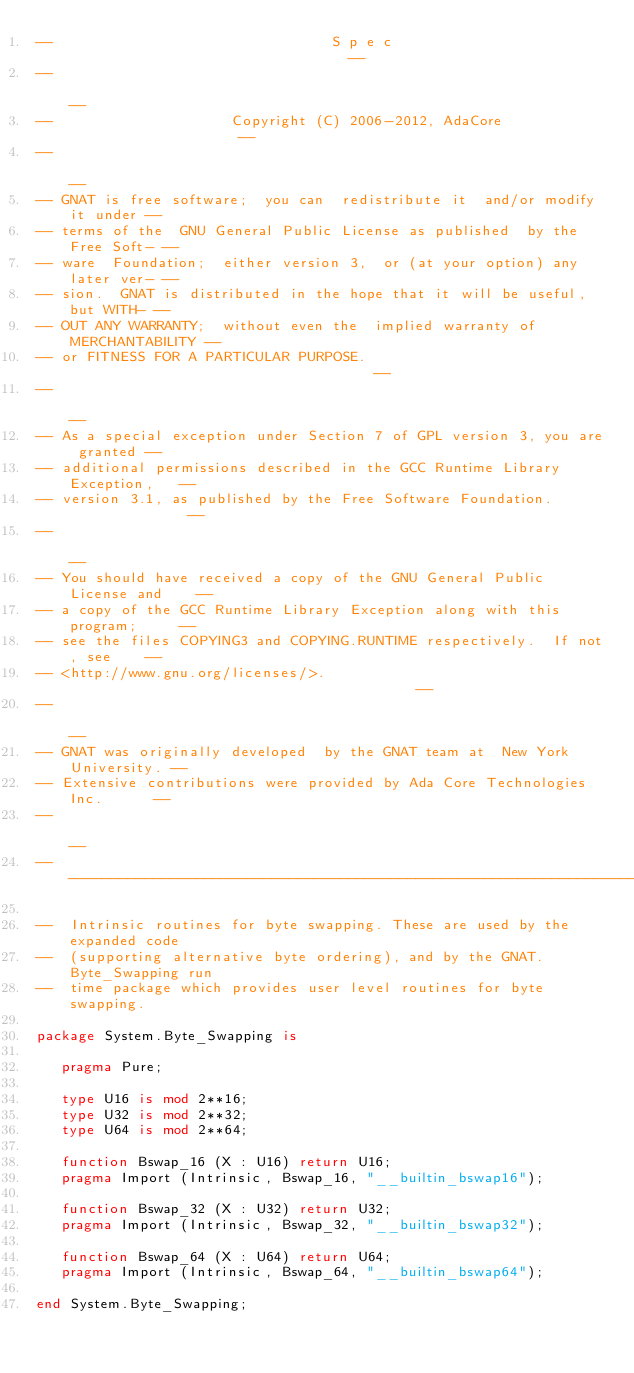Convert code to text. <code><loc_0><loc_0><loc_500><loc_500><_Ada_>--                                 S p e c                                  --
--                                                                          --
--                     Copyright (C) 2006-2012, AdaCore                     --
--                                                                          --
-- GNAT is free software;  you can  redistribute it  and/or modify it under --
-- terms of the  GNU General Public License as published  by the Free Soft- --
-- ware  Foundation;  either version 3,  or (at your option) any later ver- --
-- sion.  GNAT is distributed in the hope that it will be useful, but WITH- --
-- OUT ANY WARRANTY;  without even the  implied warranty of MERCHANTABILITY --
-- or FITNESS FOR A PARTICULAR PURPOSE.                                     --
--                                                                          --
-- As a special exception under Section 7 of GPL version 3, you are granted --
-- additional permissions described in the GCC Runtime Library Exception,   --
-- version 3.1, as published by the Free Software Foundation.               --
--                                                                          --
-- You should have received a copy of the GNU General Public License and    --
-- a copy of the GCC Runtime Library Exception along with this program;     --
-- see the files COPYING3 and COPYING.RUNTIME respectively.  If not, see    --
-- <http://www.gnu.org/licenses/>.                                          --
--                                                                          --
-- GNAT was originally developed  by the GNAT team at  New York University. --
-- Extensive contributions were provided by Ada Core Technologies Inc.      --
--                                                                          --
------------------------------------------------------------------------------

--  Intrinsic routines for byte swapping. These are used by the expanded code
--  (supporting alternative byte ordering), and by the GNAT.Byte_Swapping run
--  time package which provides user level routines for byte swapping.

package System.Byte_Swapping is

   pragma Pure;

   type U16 is mod 2**16;
   type U32 is mod 2**32;
   type U64 is mod 2**64;

   function Bswap_16 (X : U16) return U16;
   pragma Import (Intrinsic, Bswap_16, "__builtin_bswap16");

   function Bswap_32 (X : U32) return U32;
   pragma Import (Intrinsic, Bswap_32, "__builtin_bswap32");

   function Bswap_64 (X : U64) return U64;
   pragma Import (Intrinsic, Bswap_64, "__builtin_bswap64");

end System.Byte_Swapping;
</code> 